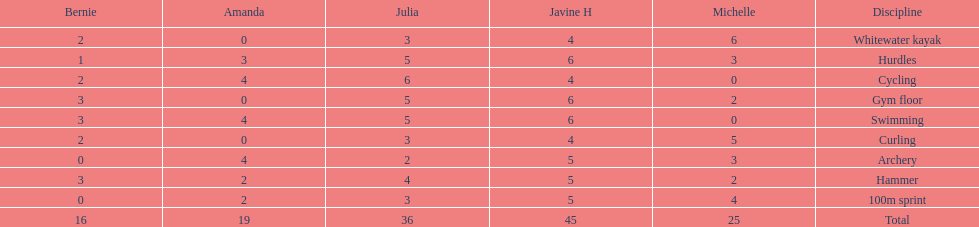Who scored the least on whitewater kayak? Amanda. 